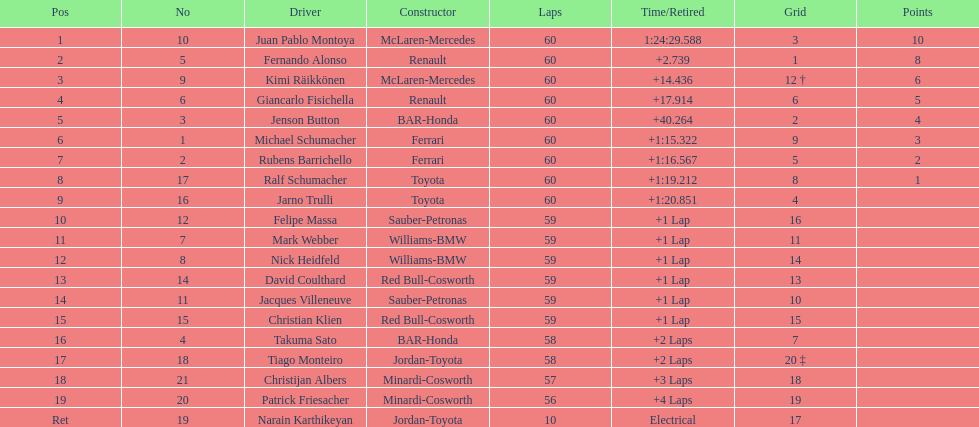What is the number of drivers who earned points in the race? 8. 